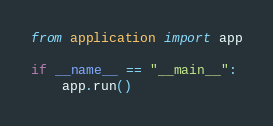Convert code to text. <code><loc_0><loc_0><loc_500><loc_500><_Python_>from application import app

if __name__ == "__main__":
    app.run()</code> 